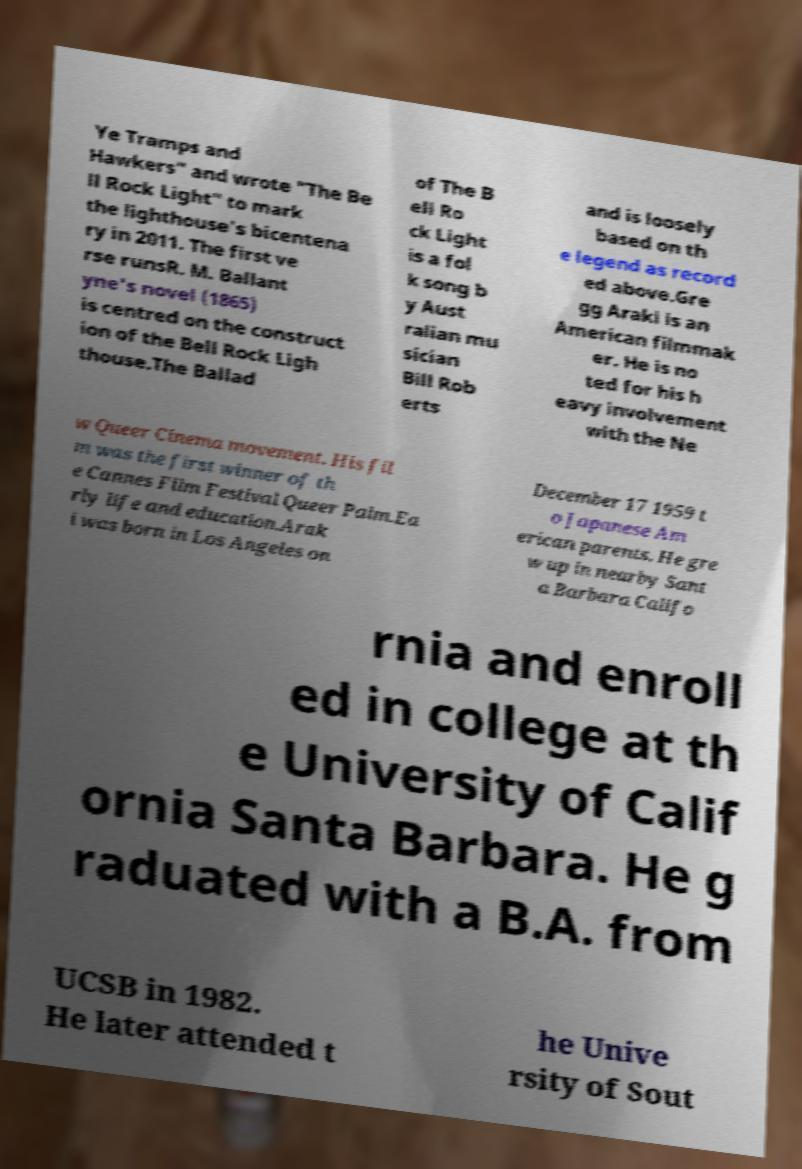There's text embedded in this image that I need extracted. Can you transcribe it verbatim? Ye Tramps and Hawkers" and wrote "The Be ll Rock Light" to mark the lighthouse's bicentena ry in 2011. The first ve rse runsR. M. Ballant yne's novel (1865) is centred on the construct ion of the Bell Rock Ligh thouse.The Ballad of The B ell Ro ck Light is a fol k song b y Aust ralian mu sician Bill Rob erts and is loosely based on th e legend as record ed above.Gre gg Araki is an American filmmak er. He is no ted for his h eavy involvement with the Ne w Queer Cinema movement. His fil m was the first winner of th e Cannes Film Festival Queer Palm.Ea rly life and education.Arak i was born in Los Angeles on December 17 1959 t o Japanese Am erican parents. He gre w up in nearby Sant a Barbara Califo rnia and enroll ed in college at th e University of Calif ornia Santa Barbara. He g raduated with a B.A. from UCSB in 1982. He later attended t he Unive rsity of Sout 